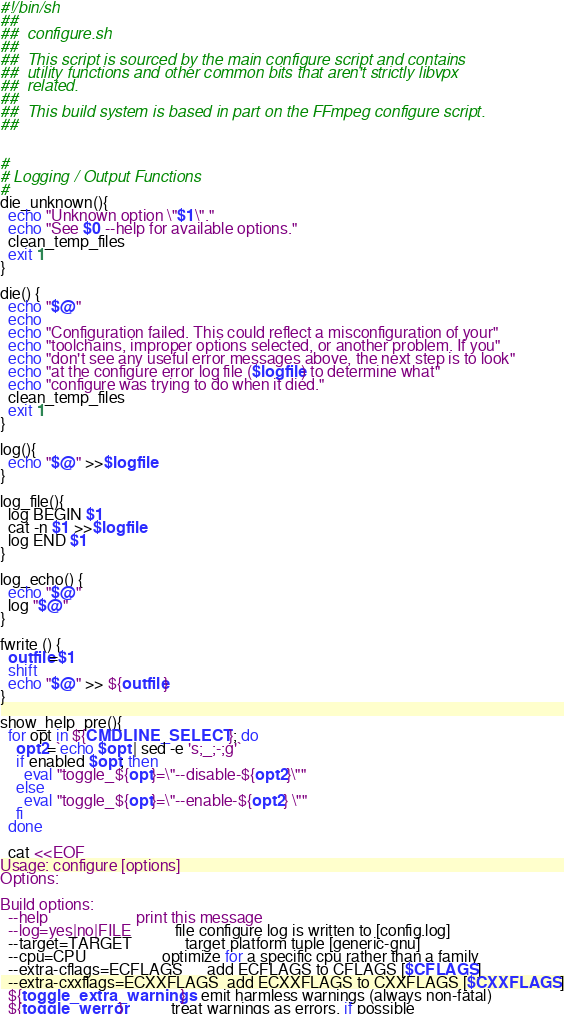Convert code to text. <code><loc_0><loc_0><loc_500><loc_500><_Bash_>#!/bin/sh
##
##  configure.sh
##
##  This script is sourced by the main configure script and contains
##  utility functions and other common bits that aren't strictly libvpx
##  related.
##
##  This build system is based in part on the FFmpeg configure script.
##


#
# Logging / Output Functions
#
die_unknown(){
  echo "Unknown option \"$1\"."
  echo "See $0 --help for available options."
  clean_temp_files
  exit 1
}

die() {
  echo "$@"
  echo
  echo "Configuration failed. This could reflect a misconfiguration of your"
  echo "toolchains, improper options selected, or another problem. If you"
  echo "don't see any useful error messages above, the next step is to look"
  echo "at the configure error log file ($logfile) to determine what"
  echo "configure was trying to do when it died."
  clean_temp_files
  exit 1
}

log(){
  echo "$@" >>$logfile
}

log_file(){
  log BEGIN $1
  cat -n $1 >>$logfile
  log END $1
}

log_echo() {
  echo "$@"
  log "$@"
}

fwrite () {
  outfile=$1
  shift
  echo "$@" >> ${outfile}
}

show_help_pre(){
  for opt in ${CMDLINE_SELECT}; do
    opt2=`echo $opt | sed -e 's;_;-;g'`
    if enabled $opt; then
      eval "toggle_${opt}=\"--disable-${opt2}\""
    else
      eval "toggle_${opt}=\"--enable-${opt2} \""
    fi
  done

  cat <<EOF
Usage: configure [options]
Options:

Build options:
  --help                      print this message
  --log=yes|no|FILE           file configure log is written to [config.log]
  --target=TARGET             target platform tuple [generic-gnu]
  --cpu=CPU                   optimize for a specific cpu rather than a family
  --extra-cflags=ECFLAGS      add ECFLAGS to CFLAGS [$CFLAGS]
  --extra-cxxflags=ECXXFLAGS  add ECXXFLAGS to CXXFLAGS [$CXXFLAGS]
  ${toggle_extra_warnings}    emit harmless warnings (always non-fatal)
  ${toggle_werror}            treat warnings as errors, if possible</code> 